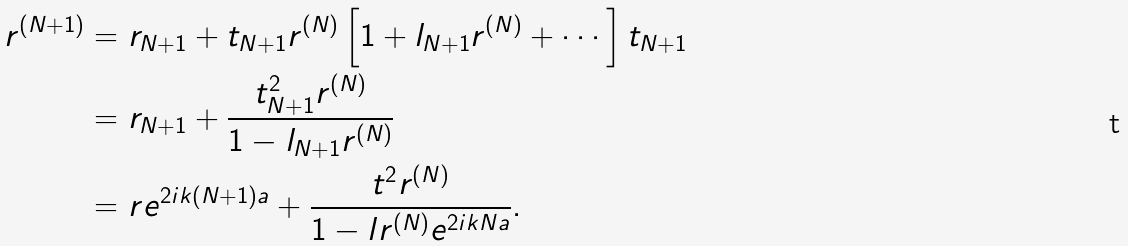<formula> <loc_0><loc_0><loc_500><loc_500>r ^ { ( N + 1 ) } & = r _ { N + 1 } + t _ { N + 1 } r ^ { ( N ) } \left [ 1 + l _ { N + 1 } r ^ { ( N ) } + \cdots \right ] t _ { N + 1 } \\ & = r _ { N + 1 } + \frac { t _ { N + 1 } ^ { 2 } r ^ { ( N ) } } { 1 - l _ { N + 1 } r ^ { ( N ) } } \\ & = r e ^ { 2 i k ( N + 1 ) a } + \frac { t ^ { 2 } r ^ { ( N ) } } { 1 - l r ^ { ( N ) } e ^ { 2 i k N a } } .</formula> 